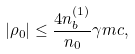<formula> <loc_0><loc_0><loc_500><loc_500>| \rho _ { 0 } | \leq \frac { 4 n _ { b } ^ { ( 1 ) } } { n _ { 0 } } \gamma m c ,</formula> 